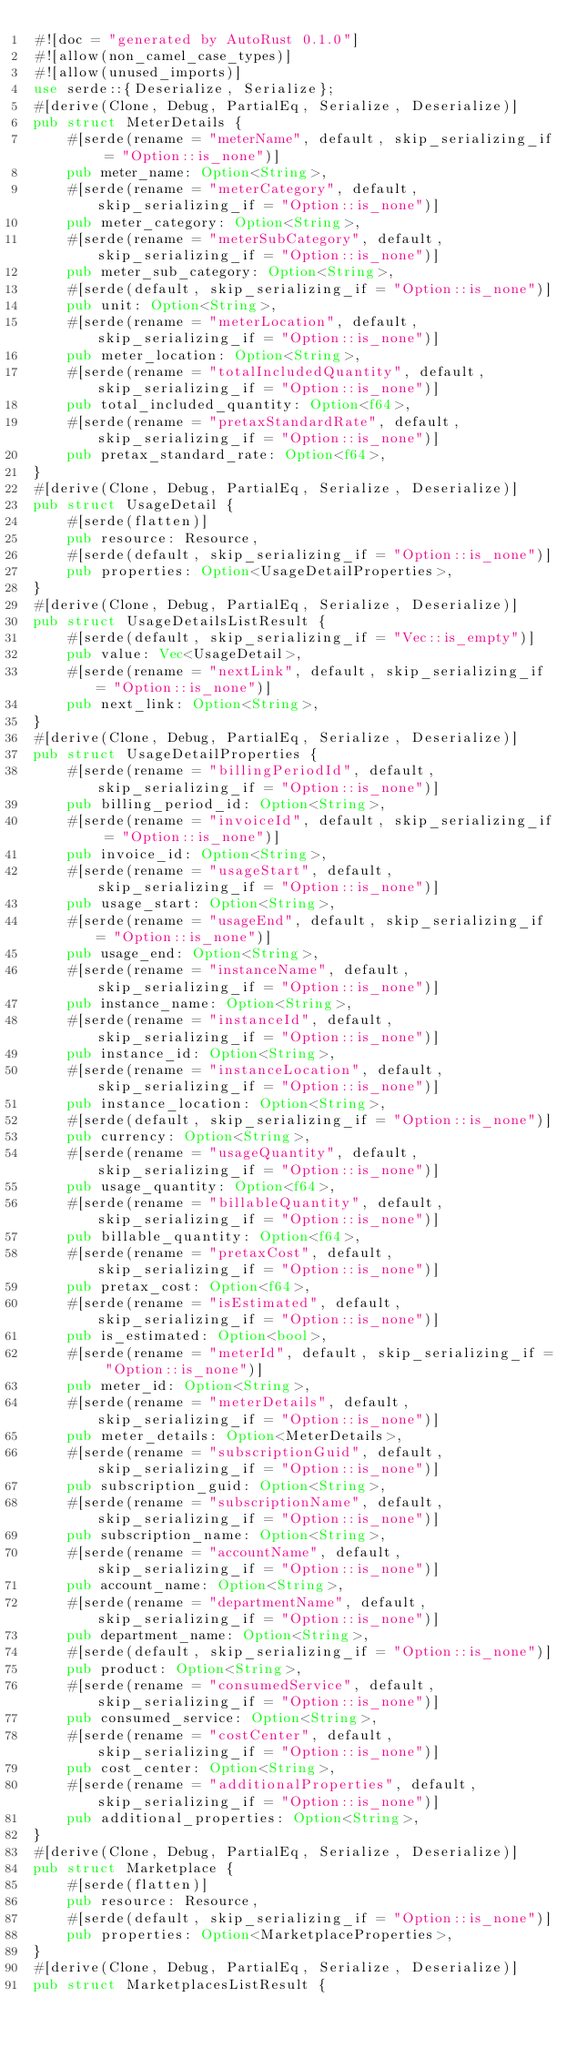<code> <loc_0><loc_0><loc_500><loc_500><_Rust_>#![doc = "generated by AutoRust 0.1.0"]
#![allow(non_camel_case_types)]
#![allow(unused_imports)]
use serde::{Deserialize, Serialize};
#[derive(Clone, Debug, PartialEq, Serialize, Deserialize)]
pub struct MeterDetails {
    #[serde(rename = "meterName", default, skip_serializing_if = "Option::is_none")]
    pub meter_name: Option<String>,
    #[serde(rename = "meterCategory", default, skip_serializing_if = "Option::is_none")]
    pub meter_category: Option<String>,
    #[serde(rename = "meterSubCategory", default, skip_serializing_if = "Option::is_none")]
    pub meter_sub_category: Option<String>,
    #[serde(default, skip_serializing_if = "Option::is_none")]
    pub unit: Option<String>,
    #[serde(rename = "meterLocation", default, skip_serializing_if = "Option::is_none")]
    pub meter_location: Option<String>,
    #[serde(rename = "totalIncludedQuantity", default, skip_serializing_if = "Option::is_none")]
    pub total_included_quantity: Option<f64>,
    #[serde(rename = "pretaxStandardRate", default, skip_serializing_if = "Option::is_none")]
    pub pretax_standard_rate: Option<f64>,
}
#[derive(Clone, Debug, PartialEq, Serialize, Deserialize)]
pub struct UsageDetail {
    #[serde(flatten)]
    pub resource: Resource,
    #[serde(default, skip_serializing_if = "Option::is_none")]
    pub properties: Option<UsageDetailProperties>,
}
#[derive(Clone, Debug, PartialEq, Serialize, Deserialize)]
pub struct UsageDetailsListResult {
    #[serde(default, skip_serializing_if = "Vec::is_empty")]
    pub value: Vec<UsageDetail>,
    #[serde(rename = "nextLink", default, skip_serializing_if = "Option::is_none")]
    pub next_link: Option<String>,
}
#[derive(Clone, Debug, PartialEq, Serialize, Deserialize)]
pub struct UsageDetailProperties {
    #[serde(rename = "billingPeriodId", default, skip_serializing_if = "Option::is_none")]
    pub billing_period_id: Option<String>,
    #[serde(rename = "invoiceId", default, skip_serializing_if = "Option::is_none")]
    pub invoice_id: Option<String>,
    #[serde(rename = "usageStart", default, skip_serializing_if = "Option::is_none")]
    pub usage_start: Option<String>,
    #[serde(rename = "usageEnd", default, skip_serializing_if = "Option::is_none")]
    pub usage_end: Option<String>,
    #[serde(rename = "instanceName", default, skip_serializing_if = "Option::is_none")]
    pub instance_name: Option<String>,
    #[serde(rename = "instanceId", default, skip_serializing_if = "Option::is_none")]
    pub instance_id: Option<String>,
    #[serde(rename = "instanceLocation", default, skip_serializing_if = "Option::is_none")]
    pub instance_location: Option<String>,
    #[serde(default, skip_serializing_if = "Option::is_none")]
    pub currency: Option<String>,
    #[serde(rename = "usageQuantity", default, skip_serializing_if = "Option::is_none")]
    pub usage_quantity: Option<f64>,
    #[serde(rename = "billableQuantity", default, skip_serializing_if = "Option::is_none")]
    pub billable_quantity: Option<f64>,
    #[serde(rename = "pretaxCost", default, skip_serializing_if = "Option::is_none")]
    pub pretax_cost: Option<f64>,
    #[serde(rename = "isEstimated", default, skip_serializing_if = "Option::is_none")]
    pub is_estimated: Option<bool>,
    #[serde(rename = "meterId", default, skip_serializing_if = "Option::is_none")]
    pub meter_id: Option<String>,
    #[serde(rename = "meterDetails", default, skip_serializing_if = "Option::is_none")]
    pub meter_details: Option<MeterDetails>,
    #[serde(rename = "subscriptionGuid", default, skip_serializing_if = "Option::is_none")]
    pub subscription_guid: Option<String>,
    #[serde(rename = "subscriptionName", default, skip_serializing_if = "Option::is_none")]
    pub subscription_name: Option<String>,
    #[serde(rename = "accountName", default, skip_serializing_if = "Option::is_none")]
    pub account_name: Option<String>,
    #[serde(rename = "departmentName", default, skip_serializing_if = "Option::is_none")]
    pub department_name: Option<String>,
    #[serde(default, skip_serializing_if = "Option::is_none")]
    pub product: Option<String>,
    #[serde(rename = "consumedService", default, skip_serializing_if = "Option::is_none")]
    pub consumed_service: Option<String>,
    #[serde(rename = "costCenter", default, skip_serializing_if = "Option::is_none")]
    pub cost_center: Option<String>,
    #[serde(rename = "additionalProperties", default, skip_serializing_if = "Option::is_none")]
    pub additional_properties: Option<String>,
}
#[derive(Clone, Debug, PartialEq, Serialize, Deserialize)]
pub struct Marketplace {
    #[serde(flatten)]
    pub resource: Resource,
    #[serde(default, skip_serializing_if = "Option::is_none")]
    pub properties: Option<MarketplaceProperties>,
}
#[derive(Clone, Debug, PartialEq, Serialize, Deserialize)]
pub struct MarketplacesListResult {</code> 